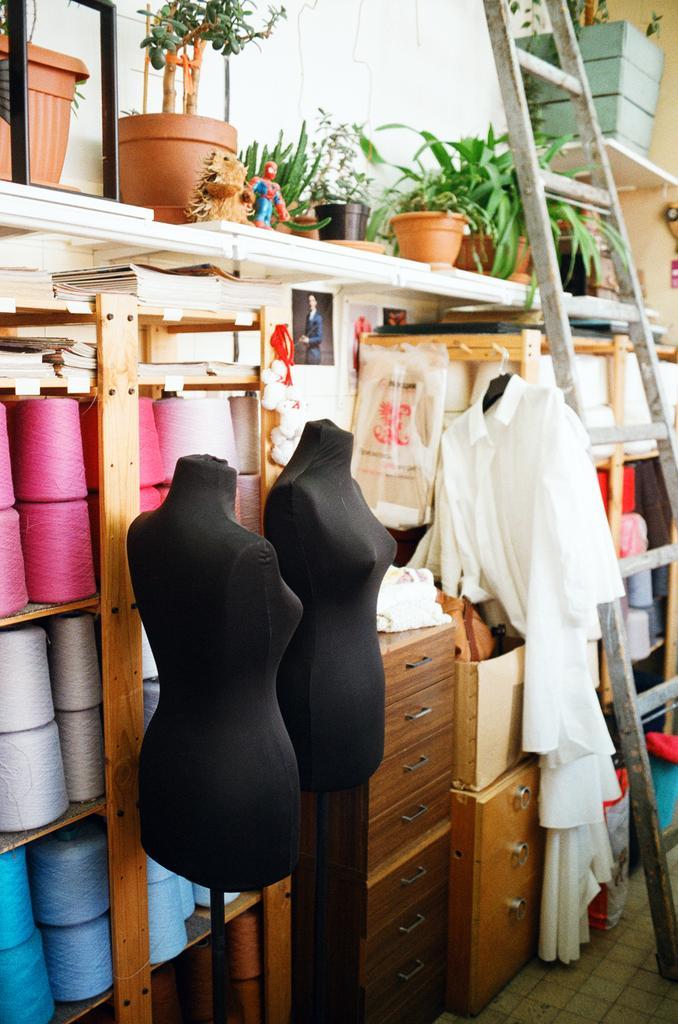How would you summarize this image in a sentence or two? In this picture we can see so many colorful roles in a shelf's, some potted plants and some clothes. 